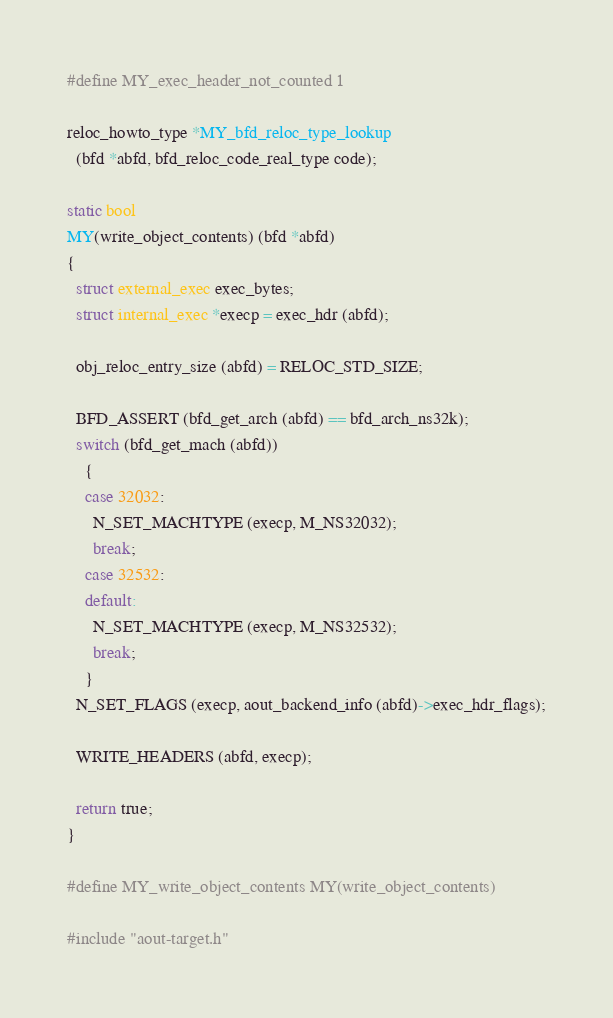Convert code to text. <code><loc_0><loc_0><loc_500><loc_500><_C_>
#define MY_exec_header_not_counted 1

reloc_howto_type *MY_bfd_reloc_type_lookup
  (bfd *abfd, bfd_reloc_code_real_type code);

static bool
MY(write_object_contents) (bfd *abfd)
{
  struct external_exec exec_bytes;
  struct internal_exec *execp = exec_hdr (abfd);

  obj_reloc_entry_size (abfd) = RELOC_STD_SIZE;

  BFD_ASSERT (bfd_get_arch (abfd) == bfd_arch_ns32k);
  switch (bfd_get_mach (abfd))
    {
    case 32032:
      N_SET_MACHTYPE (execp, M_NS32032);
      break;
    case 32532:
    default:
      N_SET_MACHTYPE (execp, M_NS32532);
      break;
    }
  N_SET_FLAGS (execp, aout_backend_info (abfd)->exec_hdr_flags);

  WRITE_HEADERS (abfd, execp);

  return true;
}

#define MY_write_object_contents MY(write_object_contents)

#include "aout-target.h"
</code> 